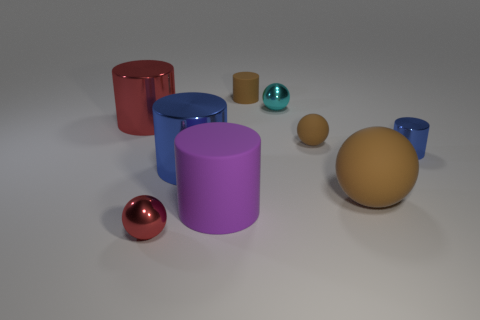How many other things are the same size as the cyan metallic ball?
Give a very brief answer. 4. What is the brown thing that is in front of the tiny shiny object that is on the right side of the small cyan metallic sphere made of?
Provide a succinct answer. Rubber. There is a brown cylinder; does it have the same size as the cylinder that is right of the brown matte cylinder?
Ensure brevity in your answer.  Yes. Is there a tiny sphere that has the same color as the big rubber sphere?
Your answer should be very brief. Yes. How many tiny things are red shiny spheres or blue cylinders?
Ensure brevity in your answer.  2. How many big brown things are there?
Give a very brief answer. 1. What is the material of the large thing on the right side of the purple thing?
Provide a succinct answer. Rubber. Are there any large purple cylinders behind the tiny red shiny ball?
Your answer should be compact. Yes. Do the red metal cylinder and the purple cylinder have the same size?
Offer a terse response. Yes. What number of small spheres are the same material as the tiny blue thing?
Make the answer very short. 2. 